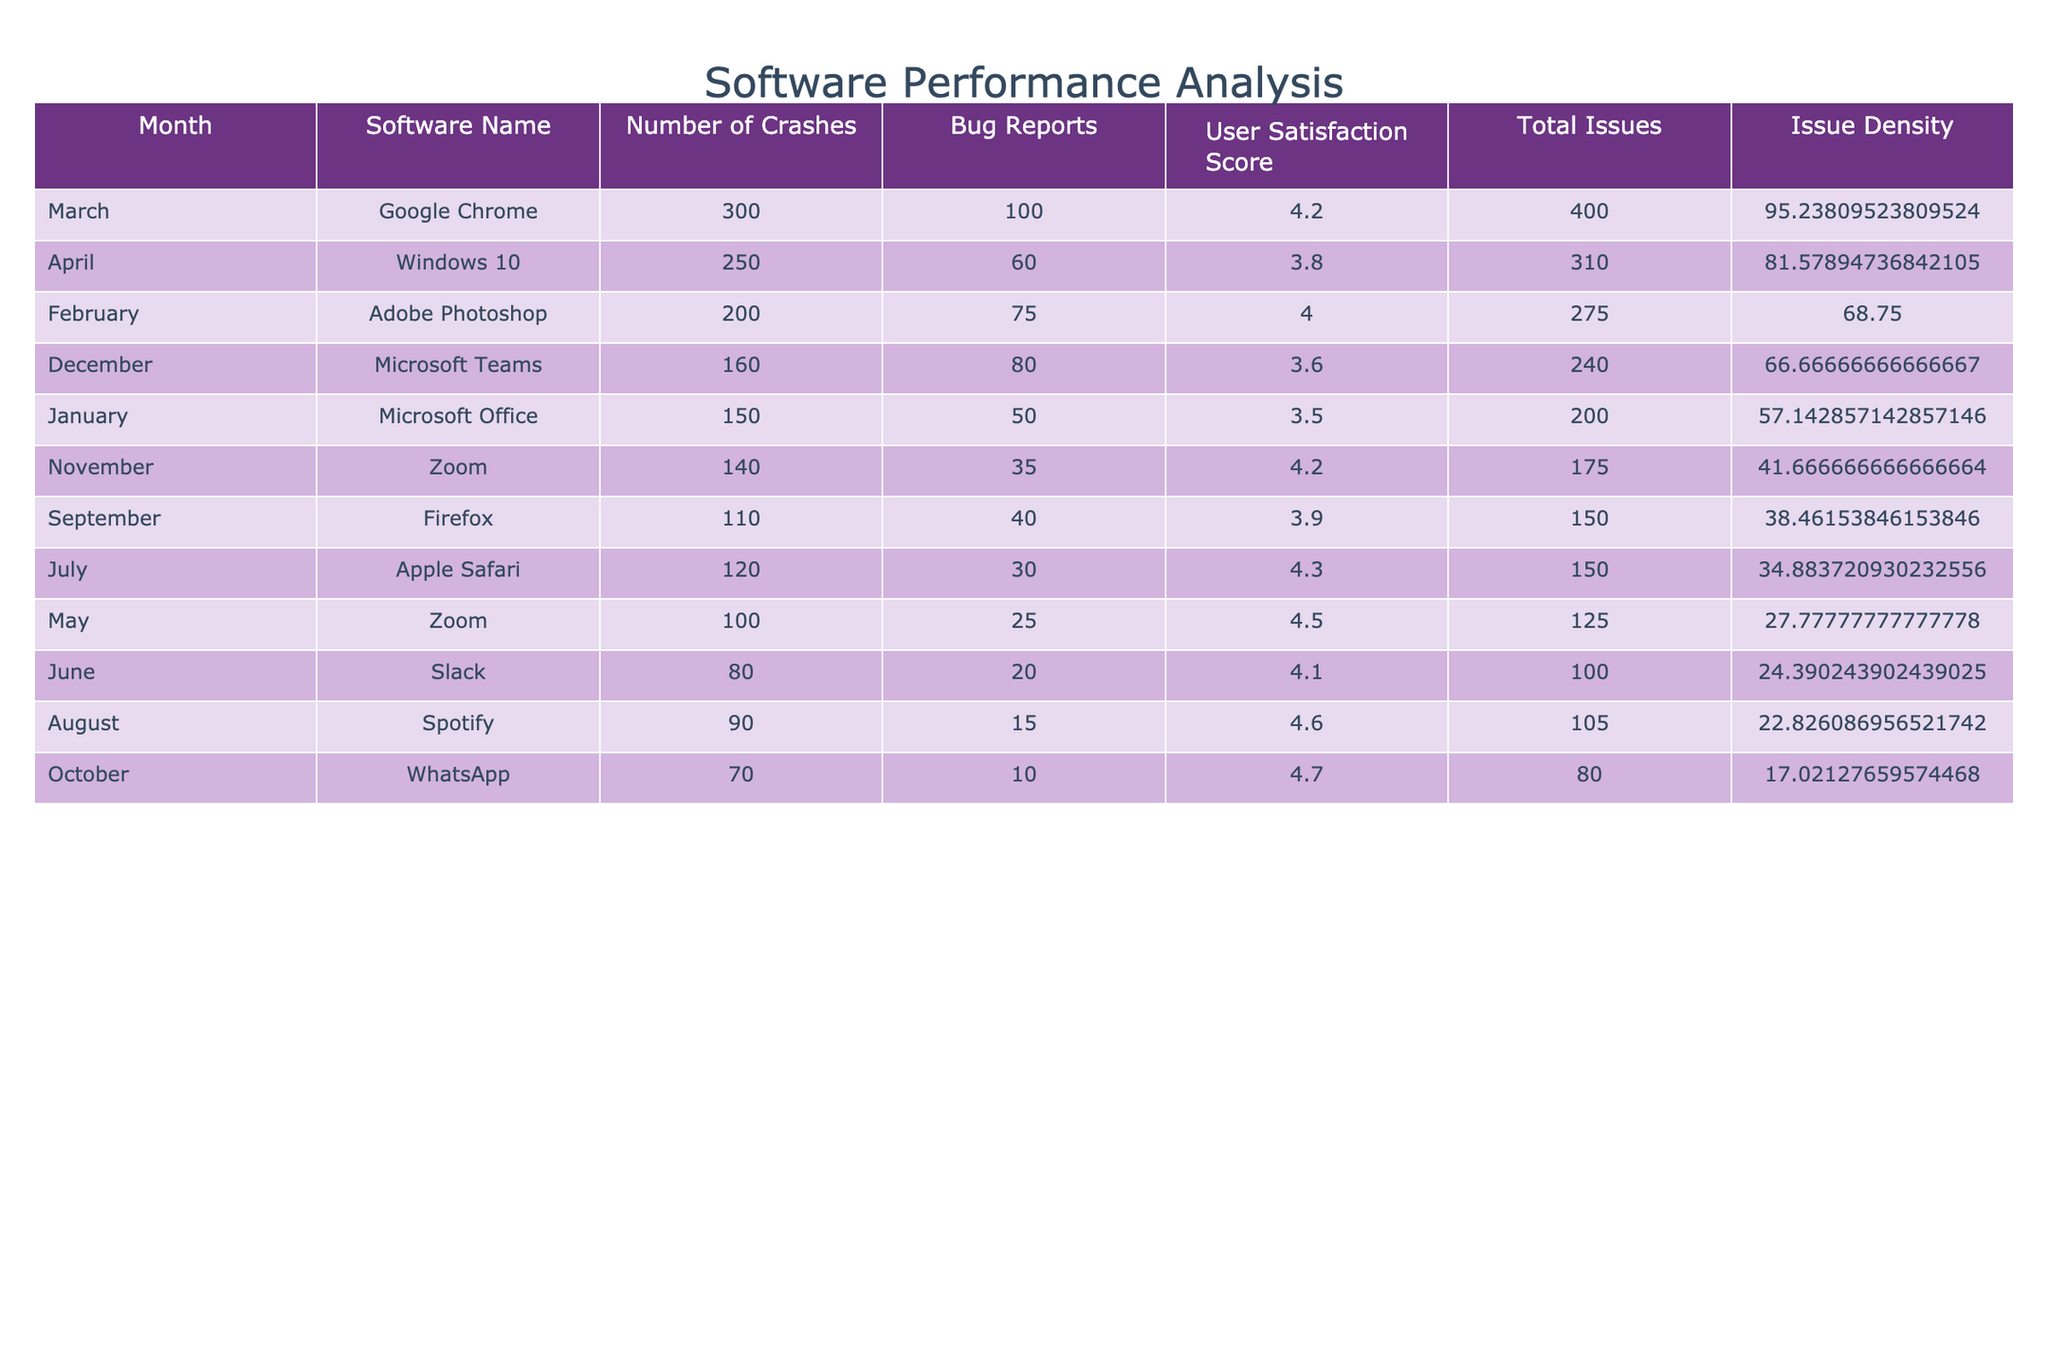What is the total number of crashes reported for Microsoft Office in January? The table shows that the number of crashes reported for Microsoft Office in January is directly listed under the "Number of Crashes" column, which is 150.
Answer: 150 Which software had the highest number of bug reports in February? According to the table, Adobe Photoshop is listed under the month of February with 75 bug reports, which is the highest amount compared to other software in the same month.
Answer: Adobe Photoshop What is the average user satisfaction score for all the software listed? To find the average user satisfaction score, sum the scores (3.5 + 4.0 + 4.2 + 3.8 + 4.5 + 4.1 + 4.3 + 4.6 + 3.9 + 4.7 + 4.2 + 3.6 = 50.3) and divide by the number of software (12). So, 50.3 / 12 = 4.19166, which rounds to approximately 4.19.
Answer: 4.19 Did Zoom experience more crashes in November than in May? In November, Zoom had 140 crashes reported, while in May it had 100 crashes. Since 140 is greater than 100, the statement is true.
Answer: Yes What is the software with the second-highest issue density? To determine the software with the second-highest issue density, first calculate the total issues and divide them by user satisfaction scores for each software, then sort them. Based on this method, Google Chrome (with 400 total issues and a satisfaction score of 4.2) has an issue density of approximately 95.24, making it the second-highest.
Answer: Google Chrome What is the difference in user satisfaction scores between the software with the most crashes and the one with the least? The software with the most crashes is Google Chrome with a user satisfaction score of 4.2, and the one with the least is WhatsApp with a score of 4.7. The difference is 4.7 - 4.2 = 0.5.
Answer: 0.5 Was the total number of crashes for Windows 10 greater than the total number of crashes for Apple Safari? Windows 10 had 250 crashes, while Apple Safari had 120 crashes. Since 250 is greater than 120, the answer is yes.
Answer: Yes Identify the month with the lowest number of bug reports. By examining the "Bug Reports" column, the lowest number is recorded in October with only 10 bug reports for WhatsApp.
Answer: October Which software had the highest total issues calculated? To find the highest total issues, sum the crashes and bug reports for all software. Google Chrome has the highest with 300 crashes and 100 bug reports, totaling 400 issues.
Answer: Google Chrome 